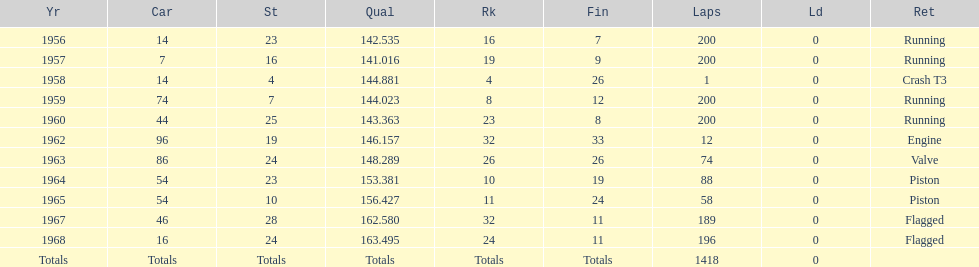When did he own a vehicle with an identical number to that of a car in 1964? 1965. 